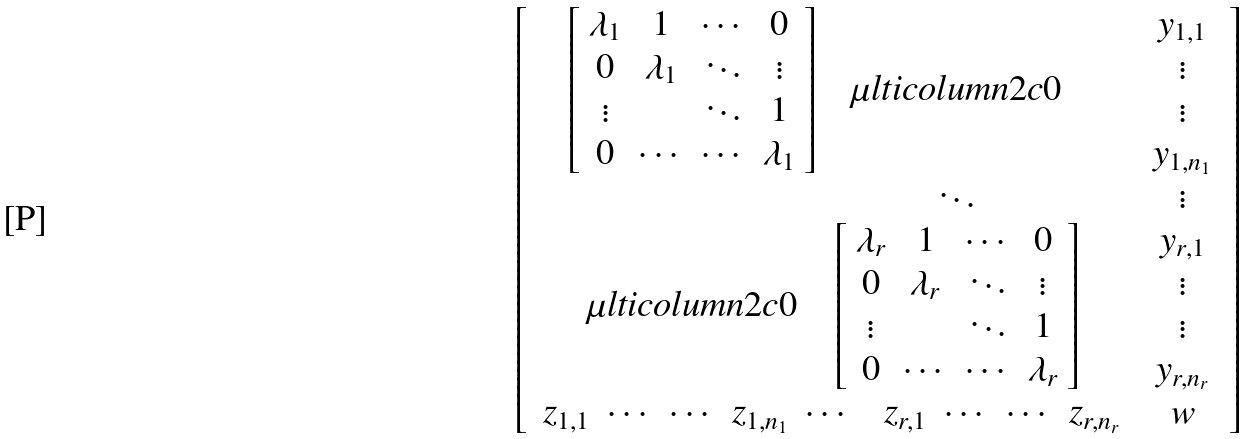Convert formula to latex. <formula><loc_0><loc_0><loc_500><loc_500>\left [ \begin{array} { c c } \begin{array} { c c c } \left [ \begin{array} { c c c c } \lambda _ { 1 } & 1 & \cdots & 0 \\ 0 & \lambda _ { 1 } & \ddots & \vdots \\ \vdots & \text { } & \ddots & 1 \\ 0 & \cdots & \cdots & \lambda _ { 1 } \\ \end{array} \right ] & \mu l t i c o l u m n { 2 } { c } { 0 } \\ & \ddots & \\ \mu l t i c o l u m n { 2 } { c } { 0 } & \left [ \begin{array} { c c c c } \lambda _ { r } & 1 & \cdots & 0 \\ 0 & \lambda _ { r } & \ddots & \vdots \\ \vdots & \text { } & \ddots & 1 \\ 0 & \cdots & \cdots & \lambda _ { r } \\ \end{array} \right ] \end{array} & \begin{array} { c } y _ { 1 , 1 } \\ \vdots \\ \vdots \\ y _ { 1 , n _ { 1 } } \\ \vdots \\ y _ { r , 1 } \\ \vdots \\ \vdots \\ y _ { r , n _ { r } } \end{array} \\ \begin{array} { c c c c c c c c c c } z _ { 1 , 1 } & \cdots & \cdots & z _ { 1 , n _ { 1 } } & \cdots & & z _ { r , 1 } & \cdots & \cdots & z _ { r , n _ { r } } \end{array} & w \end{array} \right ] \\</formula> 